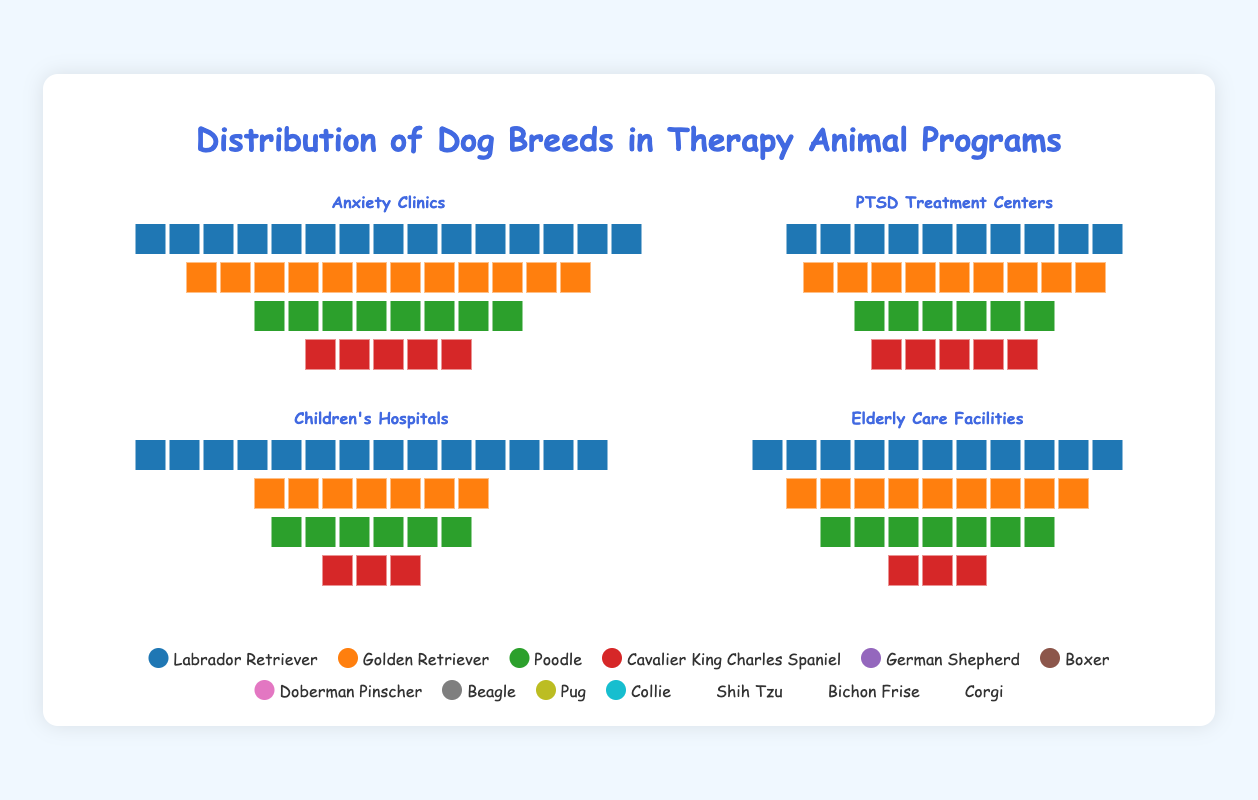What is the most common breed in Anxiety Clinics? The most common breed in Anxiety Clinics can be found by identifying the breed with the highest count in the "Anxiety Clinics" data. Labrador Retriever has the highest count at 15.
Answer: Labrador Retriever Which setting has the highest count of Golden Retrievers? To find this, compare the counts of Golden Retrievers across all settings. Anxiety Clinics have 12, PTSD Treatment Centers have none, Children's Hospitals have 14, and Elderly Care Facilities have none. The highest count is in Children's Hospitals.
Answer: Children's Hospitals How many total Poodles are used across all settings? Sum the counts of Poodles from all settings. Anxiety Clinics have 8, PTSD Treatment Centers have none, Children's Hospitals have none, and Elderly Care Facilities have 11. Therefore, the total is 8 + 11 = 19.
Answer: 19 Which breed is exclusively found in only one setting? Check the breed lists of all settings to see which breed appears in only one setting. For example, Cavalier King Charles Spaniel is only found in Anxiety Clinics.
Answer: Cavalier King Charles Spaniel What's the difference in count between Labrador Retrievers in Anxiety Clinics and PTSD Treatment Centers? Subtract the count of Labrador Retrievers in PTSD Treatment Centers from the count in Anxiety Clinics. Anxiety Clinics have 15 and PTSD Treatment Centers have 9. So, 15 - 9 = 6.
Answer: 6 What is the total number of therapy dogs in Children's Hospitals? Sum the counts of all breeds in Children's Hospitals. Golden Retriever (14), Beagle (7), Pug (6), and Collie (3). So, 14 + 7 + 6 + 3 = 30.
Answer: 30 Which breed is the second most common in Elderly Care Facilities? Identify the breed with the second highest count in Elderly Care Facilities. The top breed is Poodle with 11, followed by Shih Tzu with 9.
Answer: Shih Tzu In which setting are Collies found, and what is their count? Find the setting that lists Collies and see their count. Collies are found in Children's Hospitals with a count of 3.
Answer: Children's Hospitals, 3 What is the combined count of German Shepherds across all settings? Sum the counts of German Shepherds from all settings. German Shepherd is only found in PTSD Treatment Centers with a count of 10.
Answer: 10 Are there more Boxers or Doberman Pinschers in PTSD Treatment Centers? Compare the counts of Boxers and Doberman Pinschers in PTSD Treatment Centers. Boxers have a count of 6 and Doberman Pinschers have a count of 5. Boxers have a higher count.
Answer: Boxers 